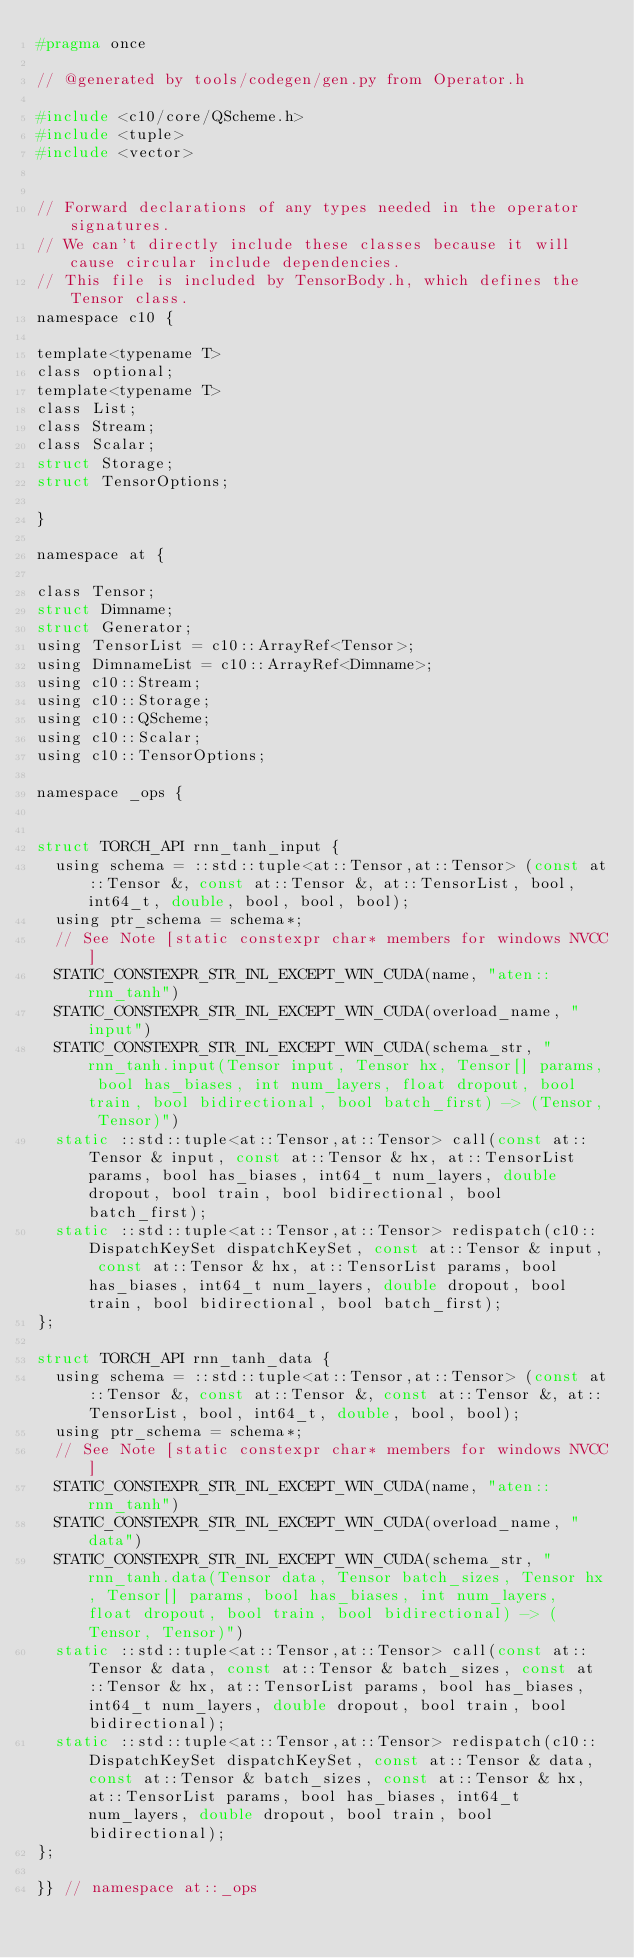Convert code to text. <code><loc_0><loc_0><loc_500><loc_500><_C_>#pragma once

// @generated by tools/codegen/gen.py from Operator.h

#include <c10/core/QScheme.h>
#include <tuple>
#include <vector>


// Forward declarations of any types needed in the operator signatures.
// We can't directly include these classes because it will cause circular include dependencies.
// This file is included by TensorBody.h, which defines the Tensor class.
namespace c10 {

template<typename T>
class optional;
template<typename T>
class List;
class Stream;
class Scalar;
struct Storage;
struct TensorOptions;

}

namespace at {

class Tensor;
struct Dimname;
struct Generator;
using TensorList = c10::ArrayRef<Tensor>;
using DimnameList = c10::ArrayRef<Dimname>;
using c10::Stream;
using c10::Storage;
using c10::QScheme;
using c10::Scalar;
using c10::TensorOptions;

namespace _ops {


struct TORCH_API rnn_tanh_input {
  using schema = ::std::tuple<at::Tensor,at::Tensor> (const at::Tensor &, const at::Tensor &, at::TensorList, bool, int64_t, double, bool, bool, bool);
  using ptr_schema = schema*;
  // See Note [static constexpr char* members for windows NVCC]
  STATIC_CONSTEXPR_STR_INL_EXCEPT_WIN_CUDA(name, "aten::rnn_tanh")
  STATIC_CONSTEXPR_STR_INL_EXCEPT_WIN_CUDA(overload_name, "input")
  STATIC_CONSTEXPR_STR_INL_EXCEPT_WIN_CUDA(schema_str, "rnn_tanh.input(Tensor input, Tensor hx, Tensor[] params, bool has_biases, int num_layers, float dropout, bool train, bool bidirectional, bool batch_first) -> (Tensor, Tensor)")
  static ::std::tuple<at::Tensor,at::Tensor> call(const at::Tensor & input, const at::Tensor & hx, at::TensorList params, bool has_biases, int64_t num_layers, double dropout, bool train, bool bidirectional, bool batch_first);
  static ::std::tuple<at::Tensor,at::Tensor> redispatch(c10::DispatchKeySet dispatchKeySet, const at::Tensor & input, const at::Tensor & hx, at::TensorList params, bool has_biases, int64_t num_layers, double dropout, bool train, bool bidirectional, bool batch_first);
};

struct TORCH_API rnn_tanh_data {
  using schema = ::std::tuple<at::Tensor,at::Tensor> (const at::Tensor &, const at::Tensor &, const at::Tensor &, at::TensorList, bool, int64_t, double, bool, bool);
  using ptr_schema = schema*;
  // See Note [static constexpr char* members for windows NVCC]
  STATIC_CONSTEXPR_STR_INL_EXCEPT_WIN_CUDA(name, "aten::rnn_tanh")
  STATIC_CONSTEXPR_STR_INL_EXCEPT_WIN_CUDA(overload_name, "data")
  STATIC_CONSTEXPR_STR_INL_EXCEPT_WIN_CUDA(schema_str, "rnn_tanh.data(Tensor data, Tensor batch_sizes, Tensor hx, Tensor[] params, bool has_biases, int num_layers, float dropout, bool train, bool bidirectional) -> (Tensor, Tensor)")
  static ::std::tuple<at::Tensor,at::Tensor> call(const at::Tensor & data, const at::Tensor & batch_sizes, const at::Tensor & hx, at::TensorList params, bool has_biases, int64_t num_layers, double dropout, bool train, bool bidirectional);
  static ::std::tuple<at::Tensor,at::Tensor> redispatch(c10::DispatchKeySet dispatchKeySet, const at::Tensor & data, const at::Tensor & batch_sizes, const at::Tensor & hx, at::TensorList params, bool has_biases, int64_t num_layers, double dropout, bool train, bool bidirectional);
};

}} // namespace at::_ops
</code> 